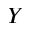<formula> <loc_0><loc_0><loc_500><loc_500>Y</formula> 